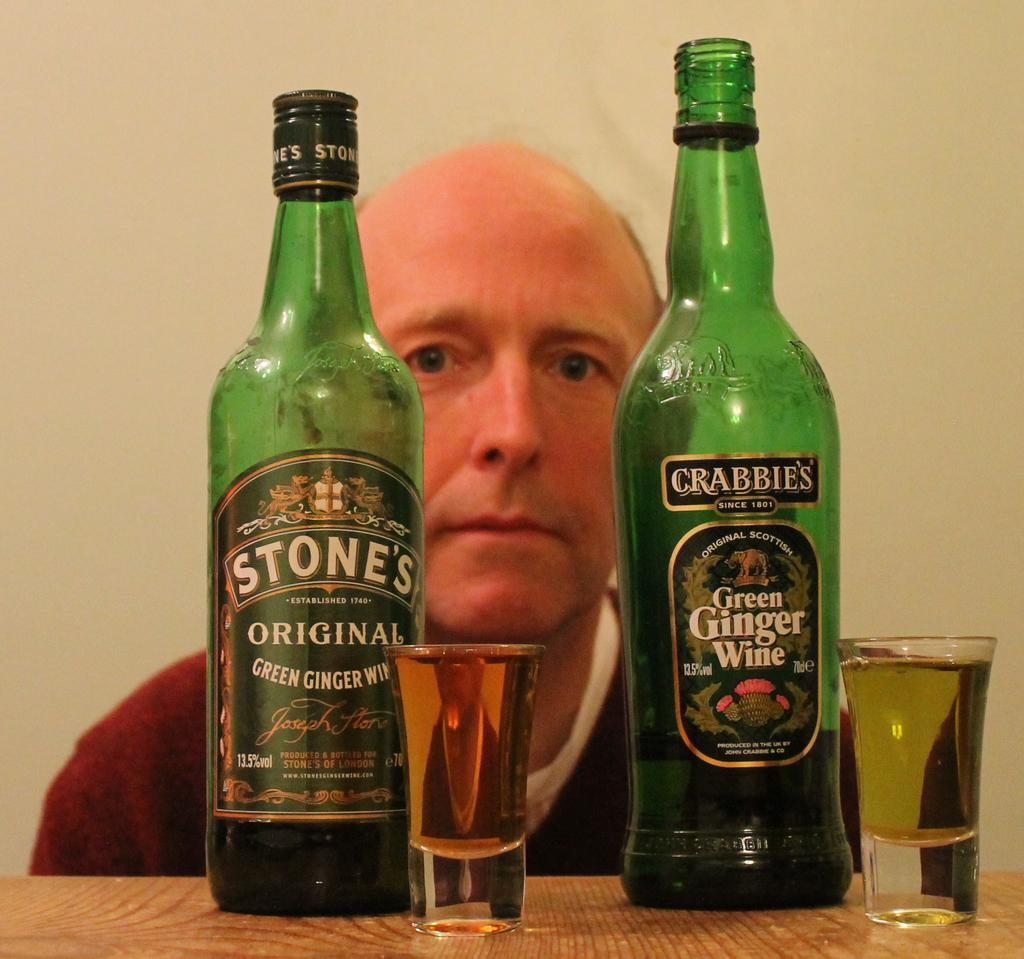<image>
Relay a brief, clear account of the picture shown. Man sit behind two bottles from different companies of Green Ginger Wine each with a shot glass full. 